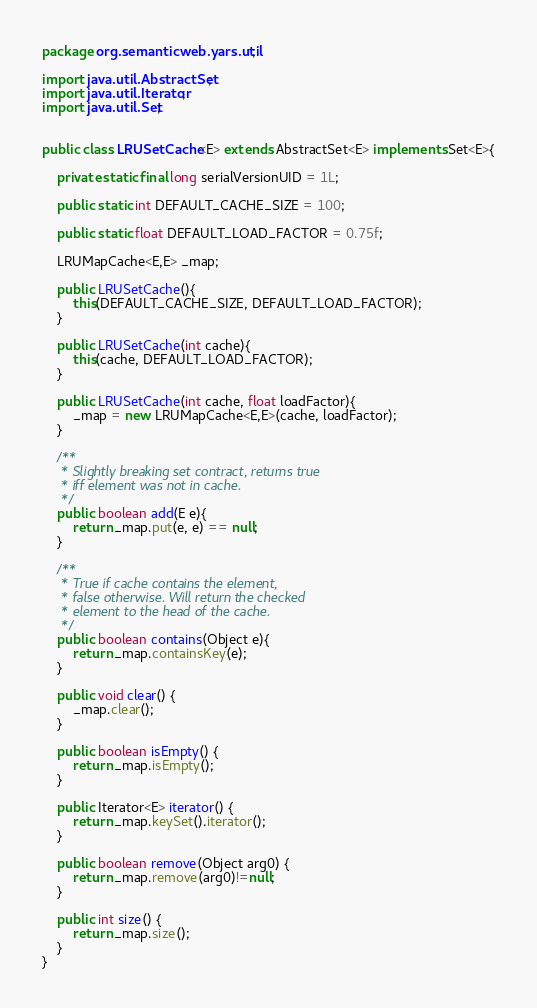Convert code to text. <code><loc_0><loc_0><loc_500><loc_500><_Java_>package org.semanticweb.yars.util;

import java.util.AbstractSet;
import java.util.Iterator;
import java.util.Set;


public class LRUSetCache<E> extends AbstractSet<E> implements Set<E>{
	
	private static final long serialVersionUID = 1L;

	public static int DEFAULT_CACHE_SIZE = 100;
	
	public static float DEFAULT_LOAD_FACTOR = 0.75f;
	
	LRUMapCache<E,E> _map;
	
	public LRUSetCache(){
		this(DEFAULT_CACHE_SIZE, DEFAULT_LOAD_FACTOR);
	}
	
	public LRUSetCache(int cache){
		this(cache, DEFAULT_LOAD_FACTOR);
	}
	
	public LRUSetCache(int cache, float loadFactor){
		_map = new LRUMapCache<E,E>(cache, loadFactor);
	}
	
	/**
	 * Slightly breaking set contract, returns true
	 * iff element was not in cache.
	 */
	public boolean add(E e){
		return _map.put(e, e) == null;
	}
	
	/**
	 * True if cache contains the element,
	 * false otherwise. Will return the checked
	 * element to the head of the cache.
	 */
	public boolean contains(Object e){
		return _map.containsKey(e);
	}
	
	public void clear() {
		_map.clear();
	}

	public boolean isEmpty() {
		return _map.isEmpty();
	}

	public Iterator<E> iterator() {
		return _map.keySet().iterator();
	}

	public boolean remove(Object arg0) {
		return _map.remove(arg0)!=null;
	}

	public int size() {
		return _map.size();
	}
}
</code> 